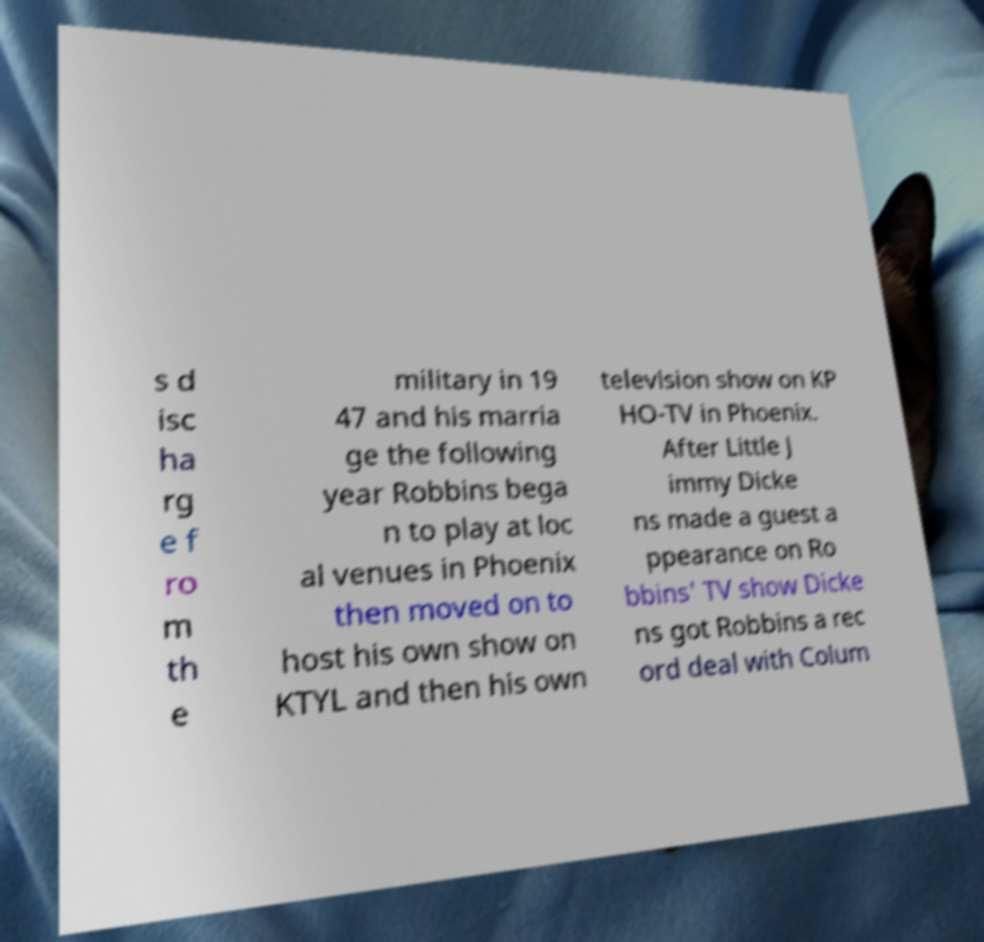Please read and relay the text visible in this image. What does it say? s d isc ha rg e f ro m th e military in 19 47 and his marria ge the following year Robbins bega n to play at loc al venues in Phoenix then moved on to host his own show on KTYL and then his own television show on KP HO-TV in Phoenix. After Little J immy Dicke ns made a guest a ppearance on Ro bbins' TV show Dicke ns got Robbins a rec ord deal with Colum 